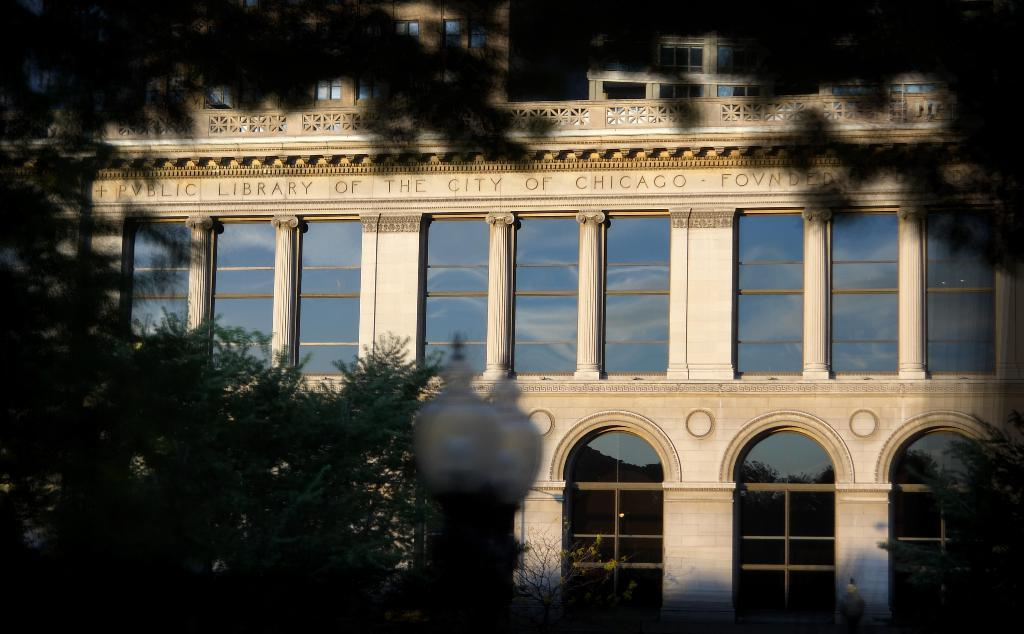What type of natural elements can be seen in the image? There are trees in the image. What type of structure is present in the image? There is a white-colored building in the image. What can be seen illuminating the scene in the image? There are lights visible in the image. What type of markings or symbols can be seen in the image? There is text written in the image. What architectural features are visible on the building in the image? There are windows in the image. Can you see any snails crawling on the building in the image? There are no snails visible in the image; the focus is on the trees, building, lights, text, and windows. What type of boot is being worn by the person in the image? There is no person present in the image, so it is impossible to determine what type of boot they might be wearing. 